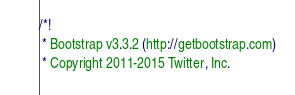Convert code to text. <code><loc_0><loc_0><loc_500><loc_500><_CSS_>/*!
 * Bootstrap v3.3.2 (http://getbootstrap.com)
 * Copyright 2011-2015 Twitter, Inc.</code> 